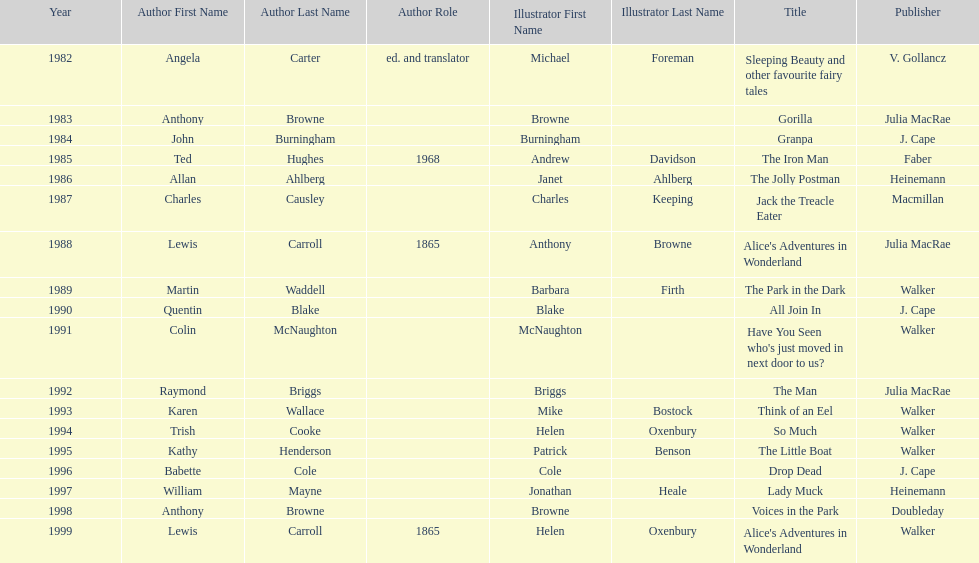What are the number of kurt maschler awards helen oxenbury has won? 2. Can you give me this table as a dict? {'header': ['Year', 'Author First Name', 'Author Last Name', 'Author Role', 'Illustrator First Name', 'Illustrator Last Name', 'Title', 'Publisher'], 'rows': [['1982', 'Angela', 'Carter', 'ed. and translator', 'Michael', 'Foreman', 'Sleeping Beauty and other favourite fairy tales', 'V. Gollancz'], ['1983', 'Anthony', 'Browne', '', 'Browne', '', 'Gorilla', 'Julia MacRae'], ['1984', 'John', 'Burningham', '', 'Burningham', '', 'Granpa', 'J. Cape'], ['1985', 'Ted', 'Hughes', '1968', 'Andrew', 'Davidson', 'The Iron Man', 'Faber'], ['1986', 'Allan', 'Ahlberg', '', 'Janet', 'Ahlberg', 'The Jolly Postman', 'Heinemann'], ['1987', 'Charles', 'Causley', '', 'Charles', 'Keeping', 'Jack the Treacle Eater', 'Macmillan'], ['1988', 'Lewis', 'Carroll', '1865', 'Anthony', 'Browne', "Alice's Adventures in Wonderland", 'Julia MacRae'], ['1989', 'Martin', 'Waddell', '', 'Barbara', 'Firth', 'The Park in the Dark', 'Walker'], ['1990', 'Quentin', 'Blake', '', 'Blake', '', 'All Join In', 'J. Cape'], ['1991', 'Colin', 'McNaughton', '', 'McNaughton', '', "Have You Seen who's just moved in next door to us?", 'Walker'], ['1992', 'Raymond', 'Briggs', '', 'Briggs', '', 'The Man', 'Julia MacRae'], ['1993', 'Karen', 'Wallace', '', 'Mike', 'Bostock', 'Think of an Eel', 'Walker'], ['1994', 'Trish', 'Cooke', '', 'Helen', 'Oxenbury', 'So Much', 'Walker'], ['1995', 'Kathy', 'Henderson', '', 'Patrick', 'Benson', 'The Little Boat', 'Walker'], ['1996', 'Babette', 'Cole', '', 'Cole', '', 'Drop Dead', 'J. Cape'], ['1997', 'William', 'Mayne', '', 'Jonathan', 'Heale', 'Lady Muck', 'Heinemann'], ['1998', 'Anthony', 'Browne', '', 'Browne', '', 'Voices in the Park', 'Doubleday'], ['1999', 'Lewis', 'Carroll', '1865', 'Helen', 'Oxenbury', "Alice's Adventures in Wonderland", 'Walker']]} 